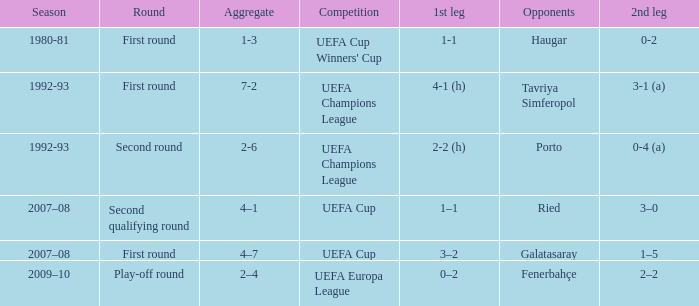 what's the competition where aggregate is 4–7 UEFA Cup. 